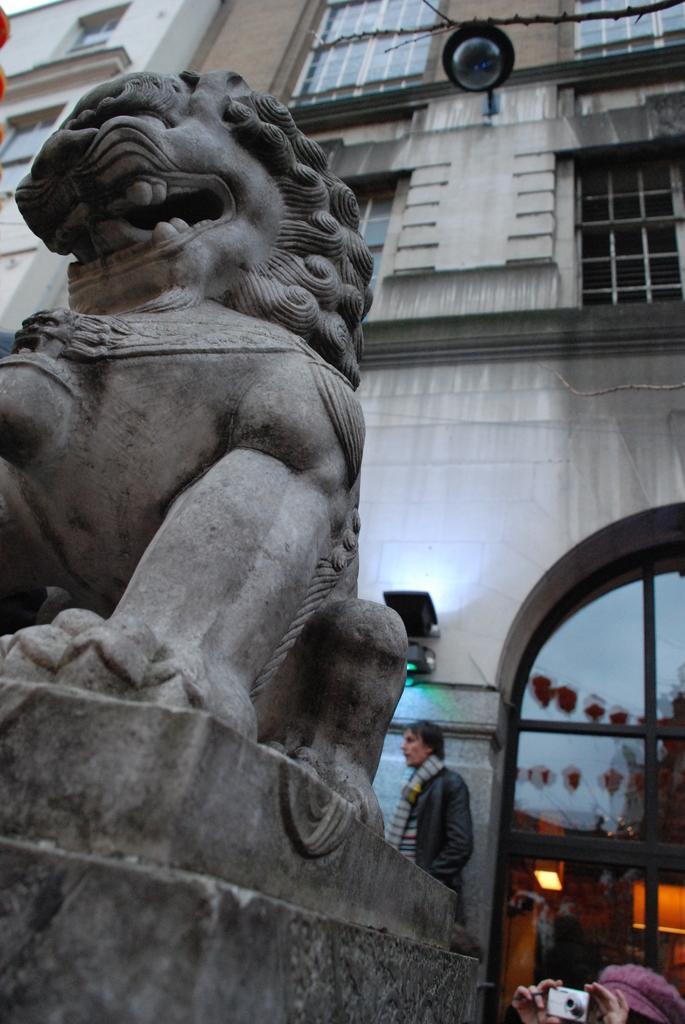Can you describe this image briefly? In the foreground I can see a lion's statue. In the background I can see buildings, windows, door and four persons. This image is taken may be during a day. 